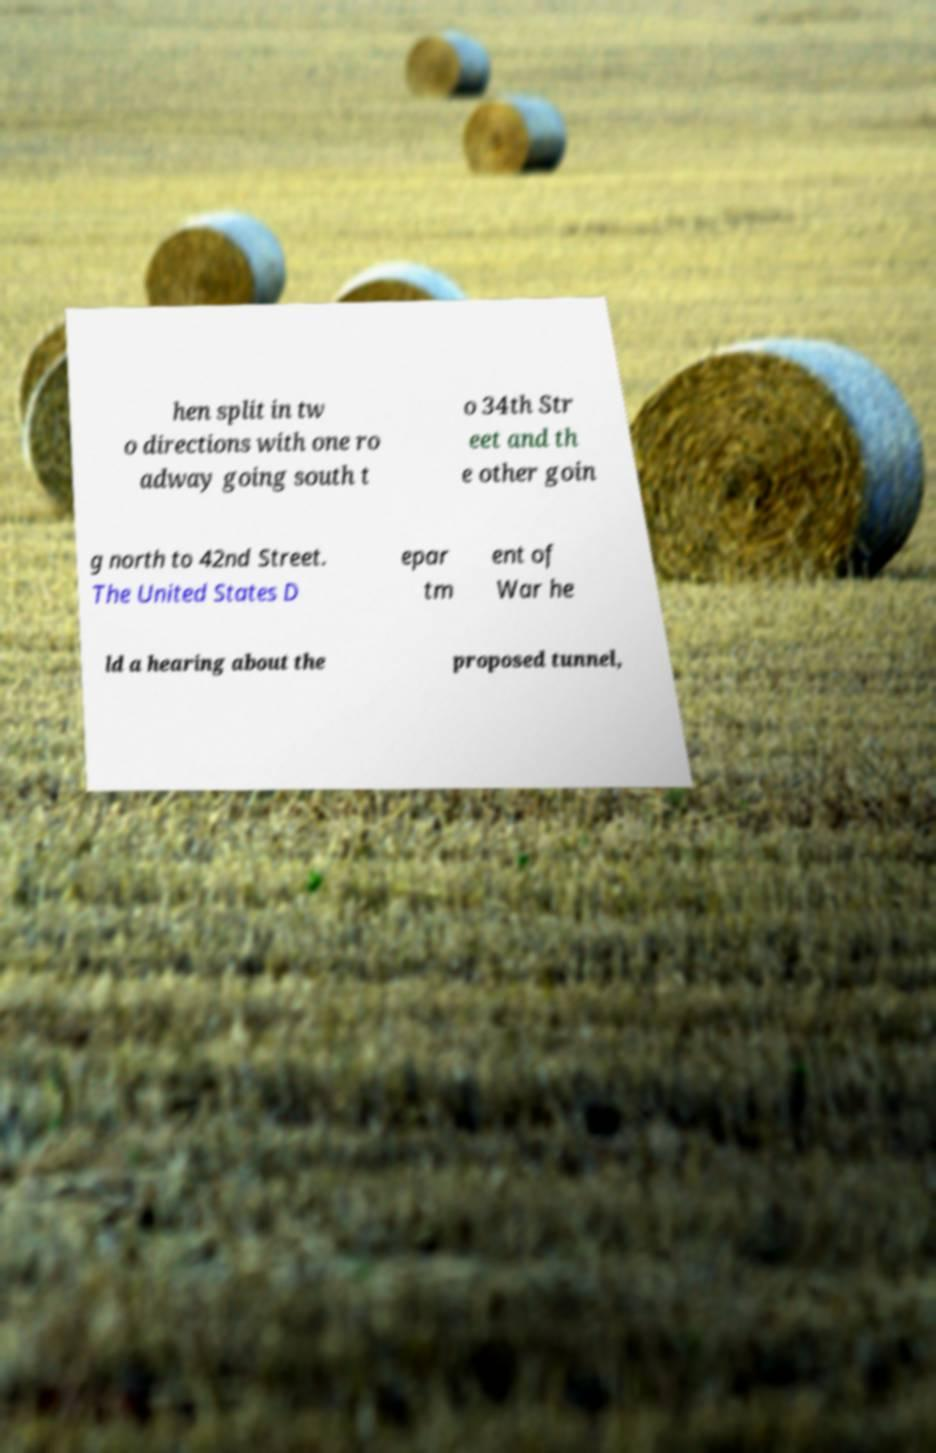Please read and relay the text visible in this image. What does it say? hen split in tw o directions with one ro adway going south t o 34th Str eet and th e other goin g north to 42nd Street. The United States D epar tm ent of War he ld a hearing about the proposed tunnel, 